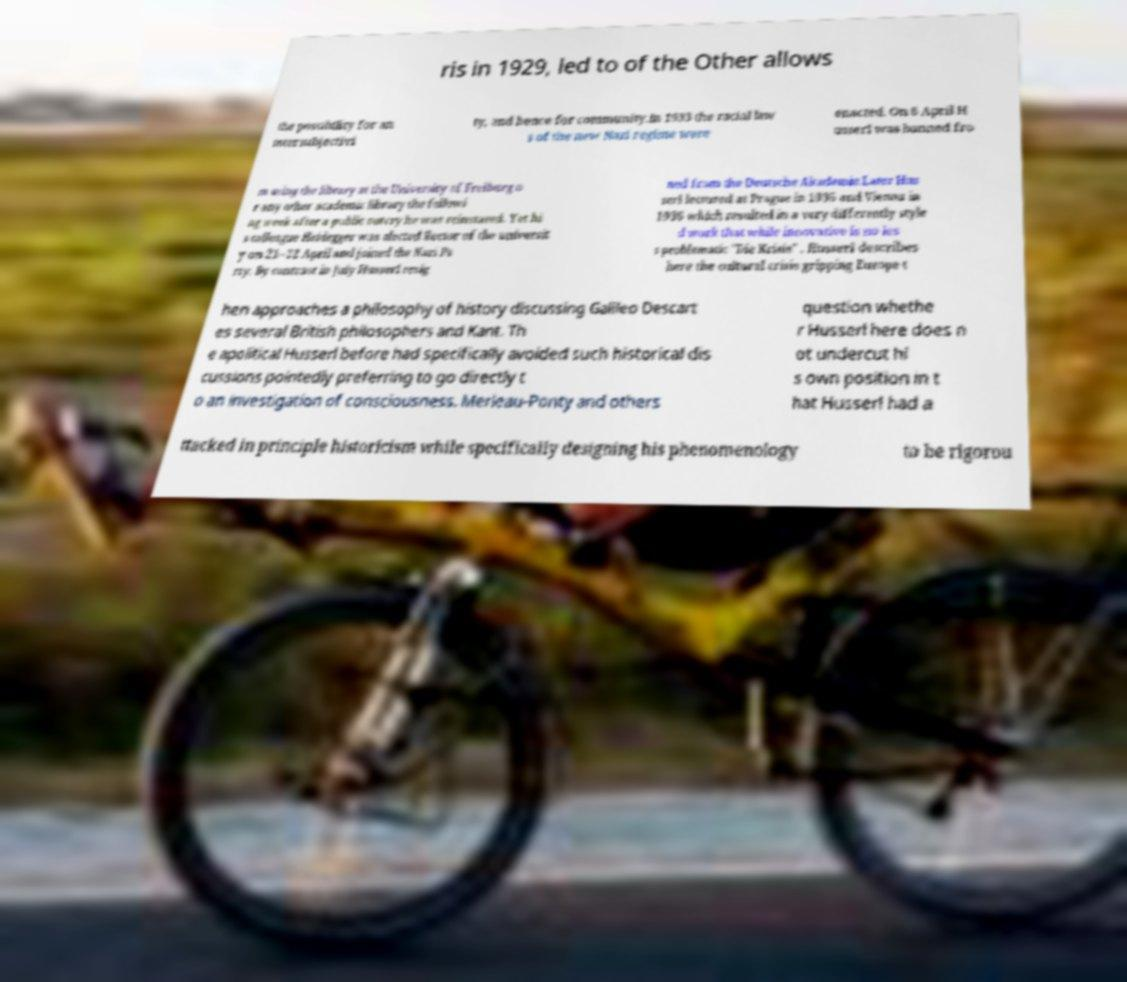Can you accurately transcribe the text from the provided image for me? ris in 1929, led to of the Other allows the possibility for an intersubjectivi ty, and hence for community.In 1933 the racial law s of the new Nazi regime were enacted. On 6 April H usserl was banned fro m using the library at the University of Freiburg o r any other academic library the followi ng week after a public outcry he was reinstated. Yet hi s colleague Heidegger was elected Rector of the universit y on 21–22 April and joined the Nazi Pa rty. By contrast in July Husserl resig ned from the Deutsche Akademie.Later Hus serl lectured at Prague in 1935 and Vienna in 1936 which resulted in a very differently style d work that while innovative is no les s problematic "Die Krisis" . Husserl describes here the cultural crisis gripping Europe t hen approaches a philosophy of history discussing Galileo Descart es several British philosophers and Kant. Th e apolitical Husserl before had specifically avoided such historical dis cussions pointedly preferring to go directly t o an investigation of consciousness. Merleau-Ponty and others question whethe r Husserl here does n ot undercut hi s own position in t hat Husserl had a ttacked in principle historicism while specifically designing his phenomenology to be rigorou 